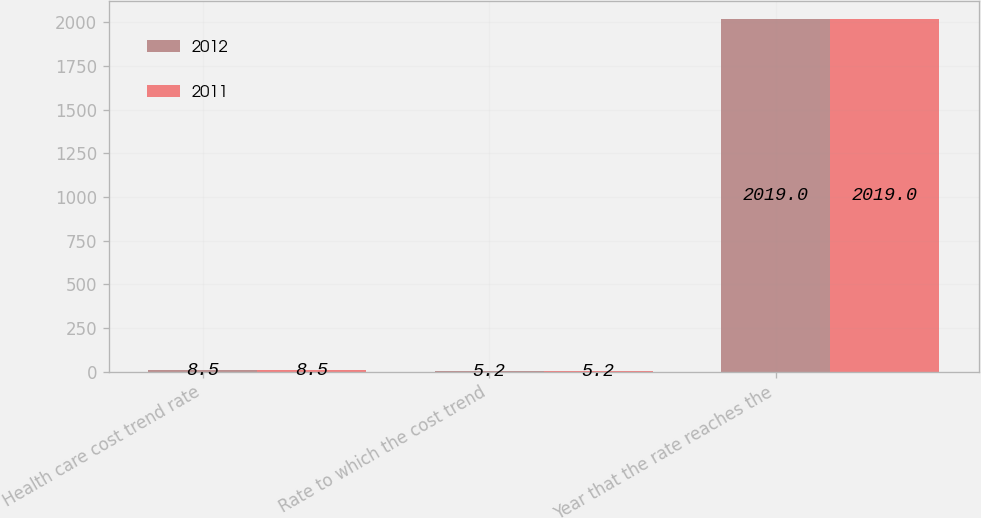Convert chart to OTSL. <chart><loc_0><loc_0><loc_500><loc_500><stacked_bar_chart><ecel><fcel>Health care cost trend rate<fcel>Rate to which the cost trend<fcel>Year that the rate reaches the<nl><fcel>2012<fcel>8.5<fcel>5.2<fcel>2019<nl><fcel>2011<fcel>8.5<fcel>5.2<fcel>2019<nl></chart> 